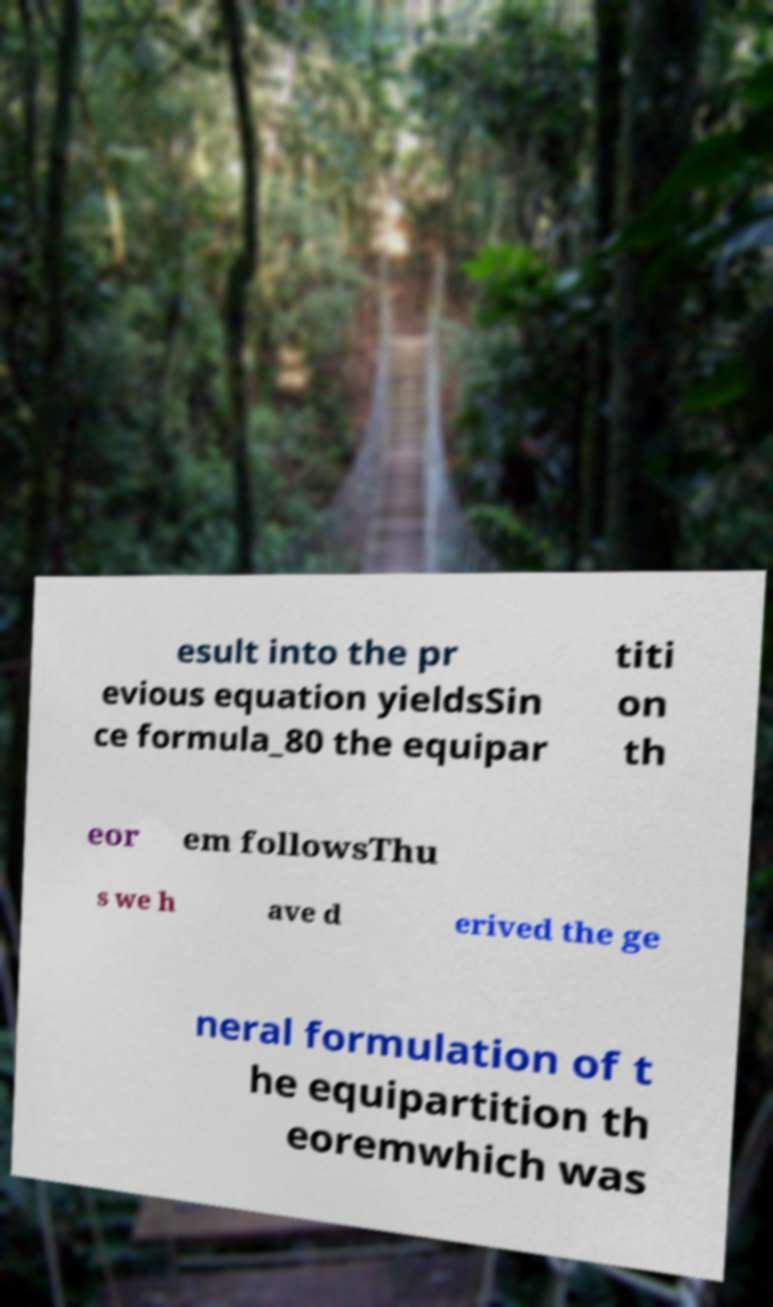What messages or text are displayed in this image? I need them in a readable, typed format. esult into the pr evious equation yieldsSin ce formula_80 the equipar titi on th eor em followsThu s we h ave d erived the ge neral formulation of t he equipartition th eoremwhich was 